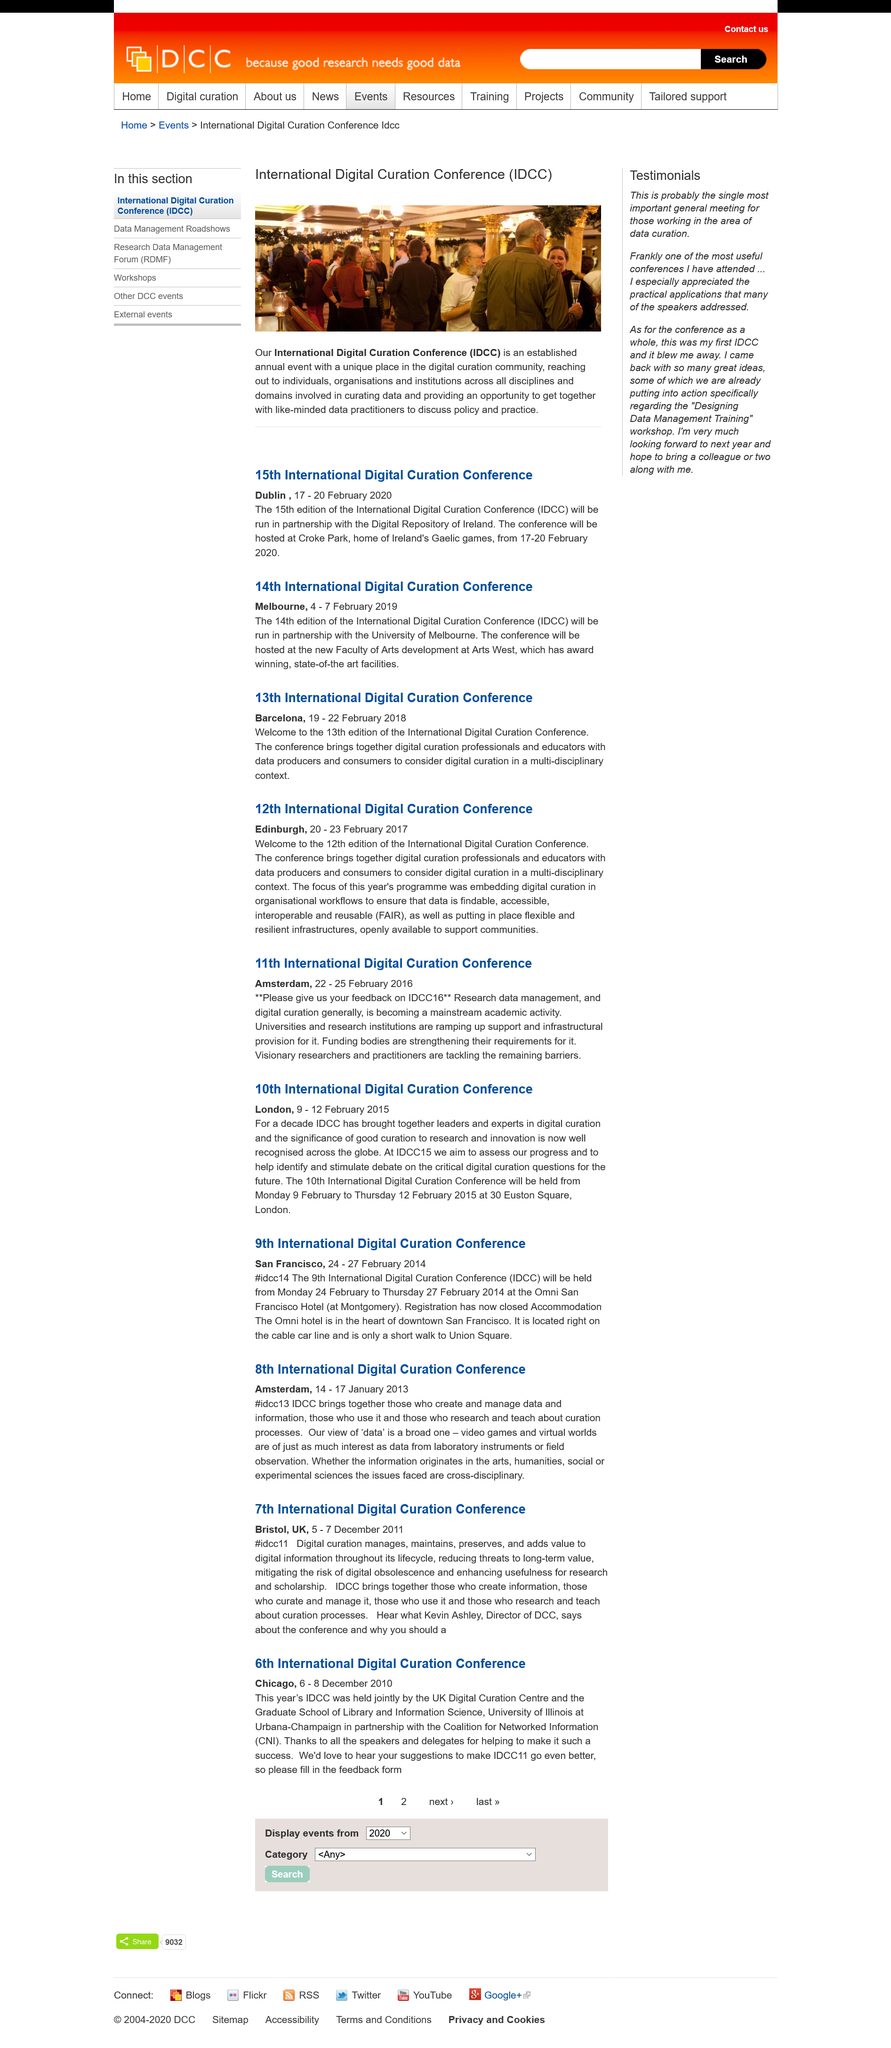Point out several critical features in this image. The 10th and 11th International Digital Curation Conferences were held in London and Amsterdam, respectively. Kevin Ashley is the Director of DCC, and his position is unknown. The 7th International Digital Curation Conference was held from 5-7 December 2011. The International Day for the Commemoration of the Slave Trade and its Abolition (IDCC) occurred in February 2015 and 2016. The acronym IDCC stands for the International Digital Curation Conference. 